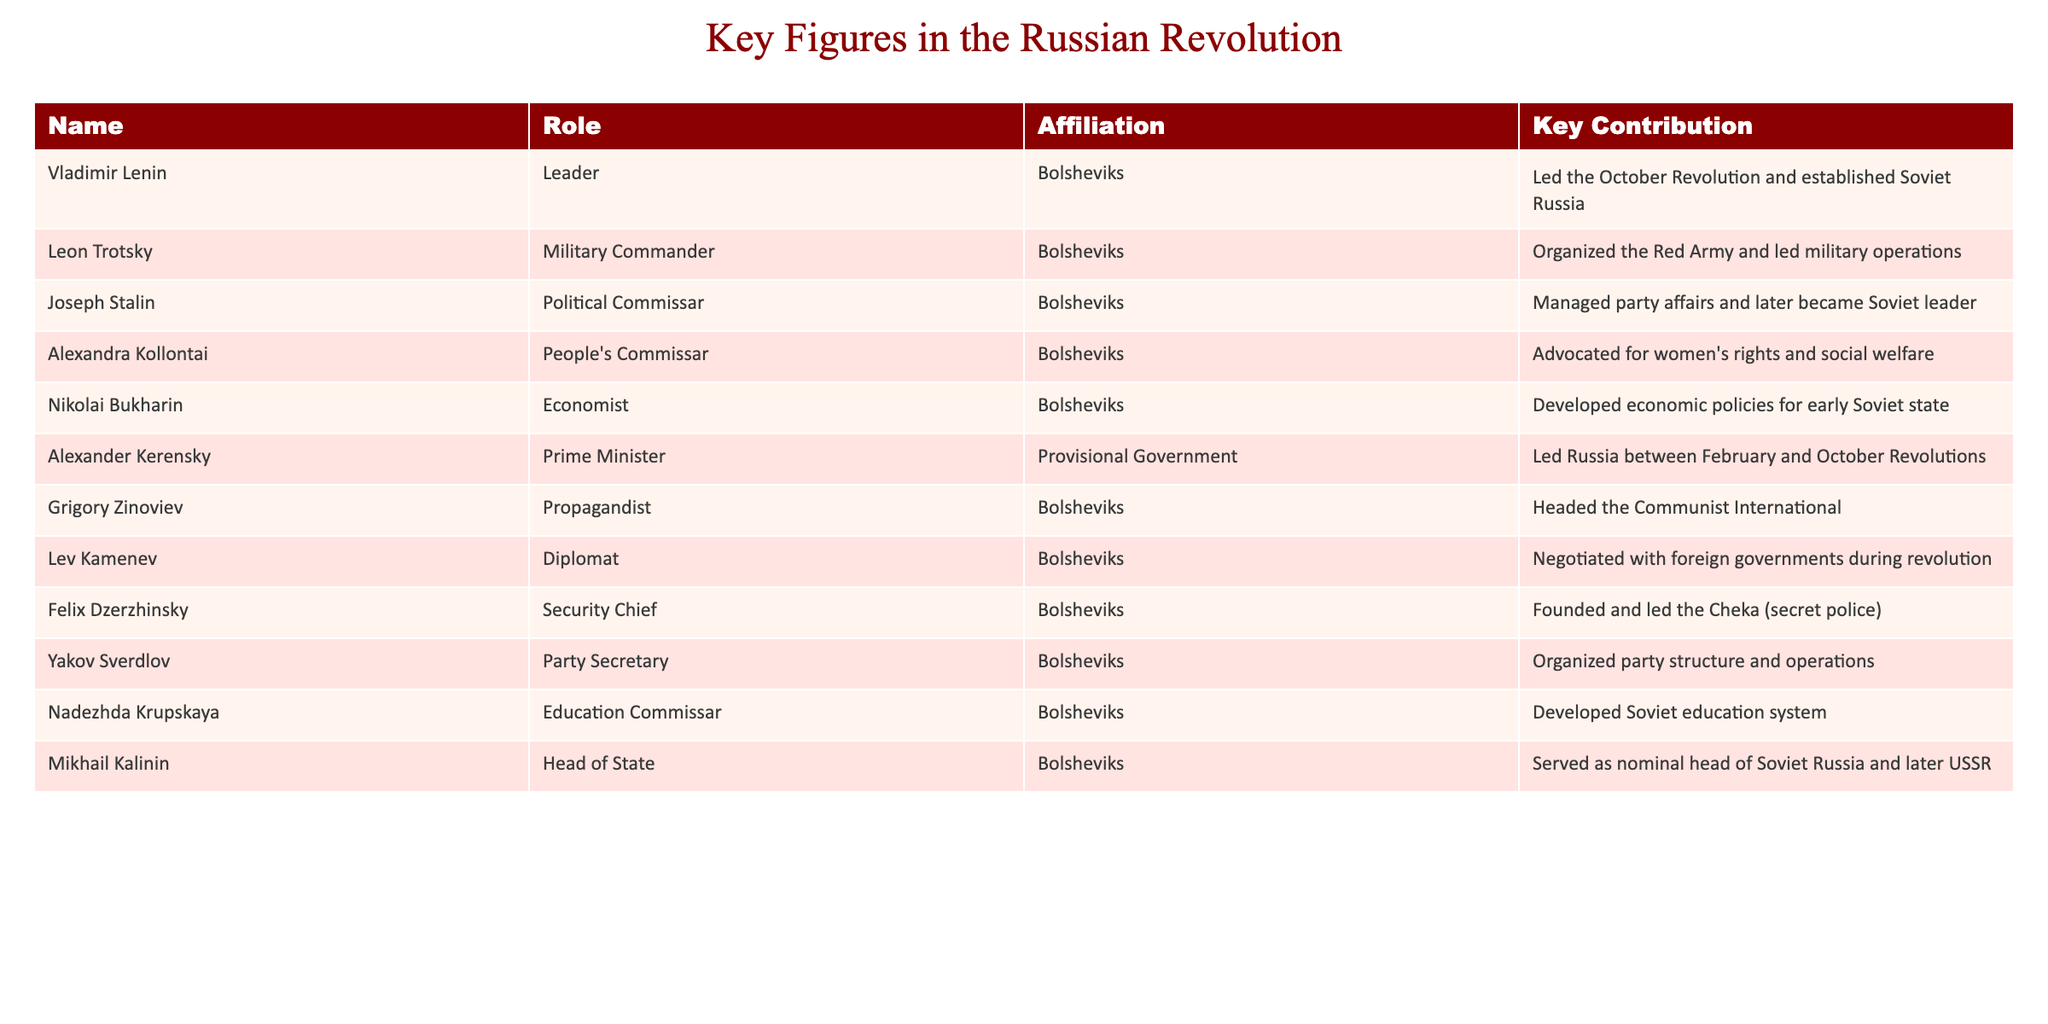What role did Vladimir Lenin play in the Russian Revolution? According to the table, Vladimir Lenin is listed as the Leader of the Bolsheviks and is noted for leading the October Revolution and establishing Soviet Russia.
Answer: Leader Who organized the Red Army during the Russian Revolution? The table indicates that Leon Trotsky served as the Military Commander for the Bolsheviks and was responsible for organizing the Red Army and leading military operations.
Answer: Leon Trotsky Which figure was responsible for founding the Cheka? From the table, it is clear that Felix Dzerzhinsky, as the Security Chief of the Bolsheviks, founded and led the Cheka, which was the secret police.
Answer: Felix Dzerzhinsky What was Joseph Stalin's role during the Russian Revolution? The table identifies Joseph Stalin as the Political Commissar for the Bolsheviks, managing party affairs and later becoming the Soviet leader.
Answer: Political Commissar Who was the Prime Minister between the February and October Revolutions? The table states that Alexander Kerensky was the Prime Minister of the Provisional Government during the time between the two revolutions.
Answer: Alexander Kerensky Did Nadezhda Krupskaya have a role in the education sector? Yes, the table indicates that Nadezhda Krupskaya was the Education Commissar and developed the Soviet education system.
Answer: Yes Who had a key contribution in advocating for women's rights? Alexandra Kollontai is mentioned in the table as having the role of People's Commissar with a key contribution in advocating for women's rights and social welfare.
Answer: Alexandra Kollontai Which Bolshevik figure was involved in negotiating with foreign governments? The table shows that Lev Kamenev served as a Diplomat for the Bolsheviks and was involved in negotiating with foreign governments during the revolution.
Answer: Lev Kamenev Name all the figures affiliated with the Bolsheviks. The table lists several figures affiliated with the Bolsheviks: Vladimir Lenin, Leon Trotsky, Joseph Stalin, Alexandra Kollontai, Nikolai Bukharin, Grigory Zinoviev, Lev Kamenev, Felix Dzerzhinsky, Yakov Sverdlov, Nadezhda Krupskaya, and Mikhail Kalinin.
Answer: 11 figures Which Bolshevik figure had the role of Party Secretary? According to the table, Yakov Sverdlov held the position of Party Secretary for the Bolsheviks.
Answer: Yakov Sverdlov How many key contributors were affiliated with the Provisional Government? The table indicates that there is one key contributor affiliated with the Provisional Government: Alexander Kerensky.
Answer: 1 Compare the roles of military and security leaders in the Bolsheviks. The military leader is Leon Trotsky, who organized the Red Army, while the security leader is Felix Dzerzhinsky, who founded and led the Cheka. This shows a division of responsibilities where one focused on military operations and the other on internal security.
Answer: Different roles: military vs. security 